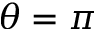<formula> <loc_0><loc_0><loc_500><loc_500>\theta = \pi</formula> 